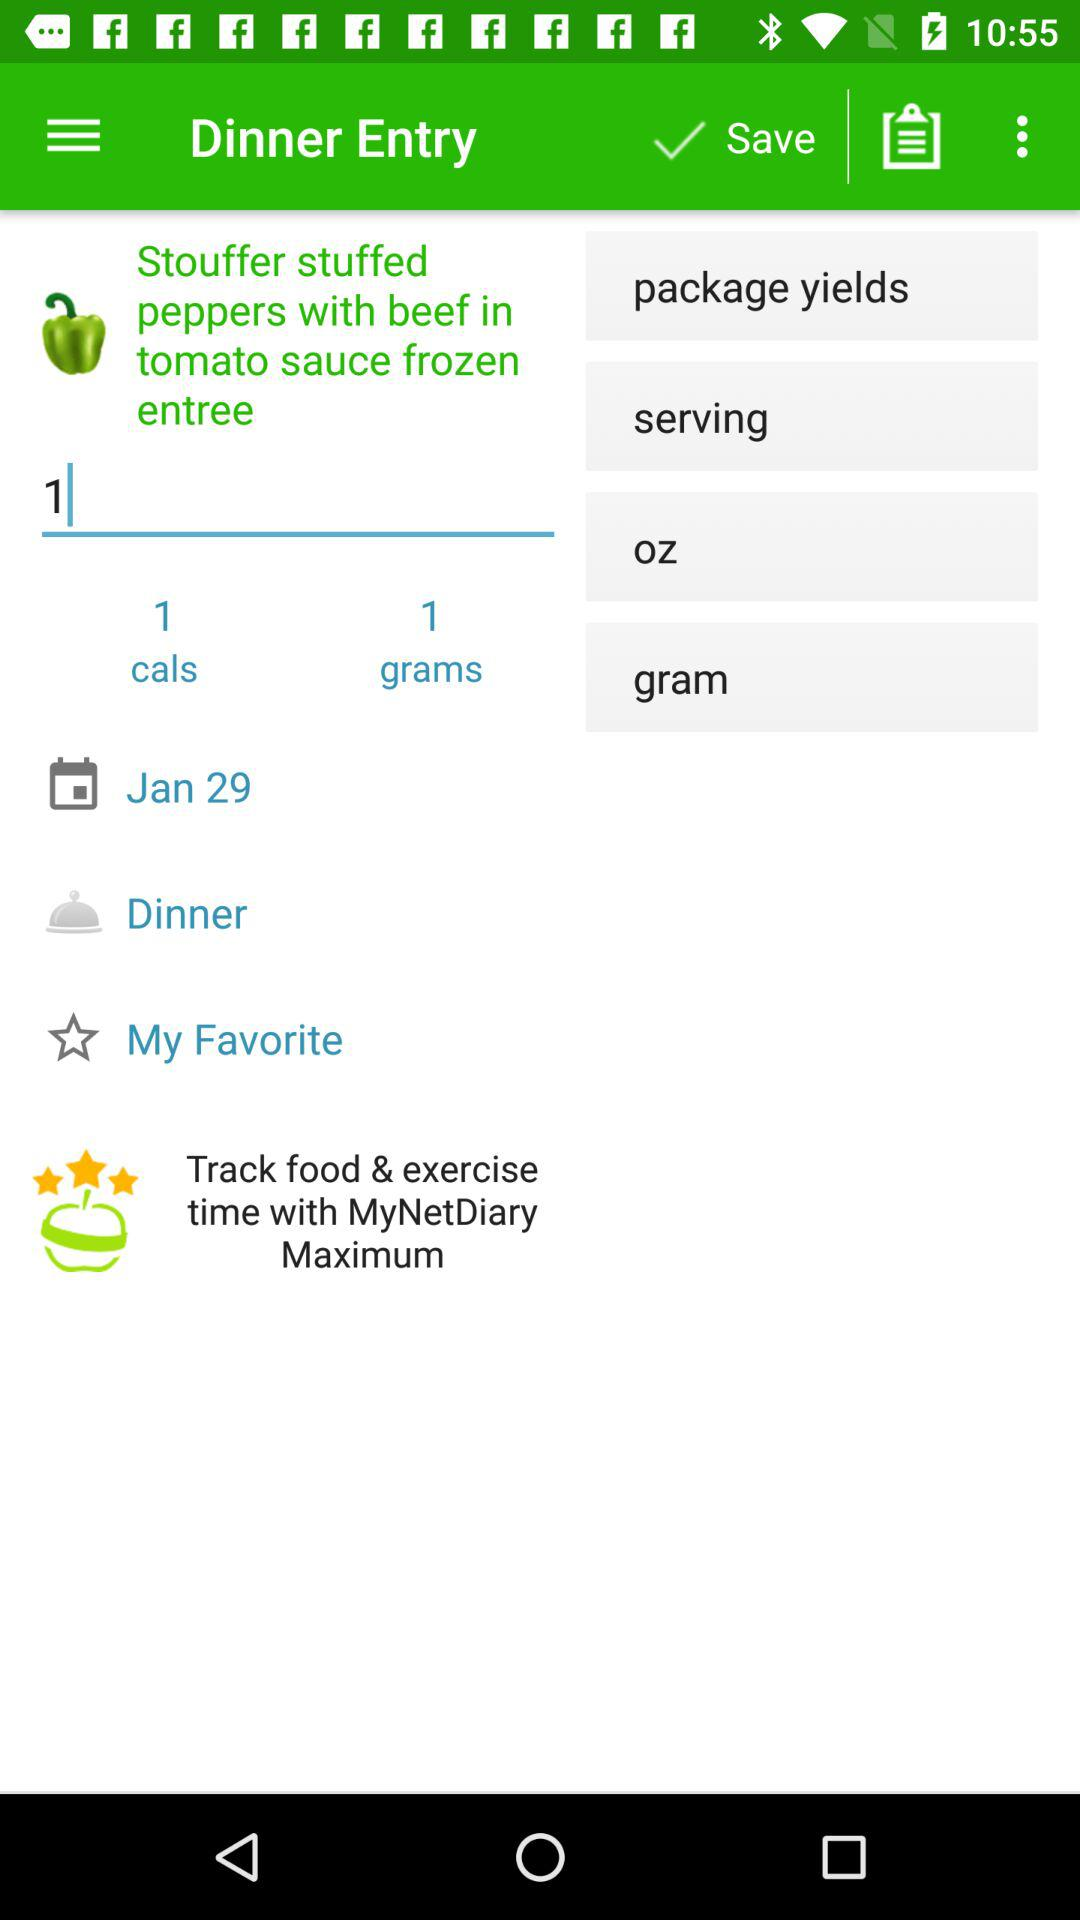How many items were ordered? There is 1 item ordered. 